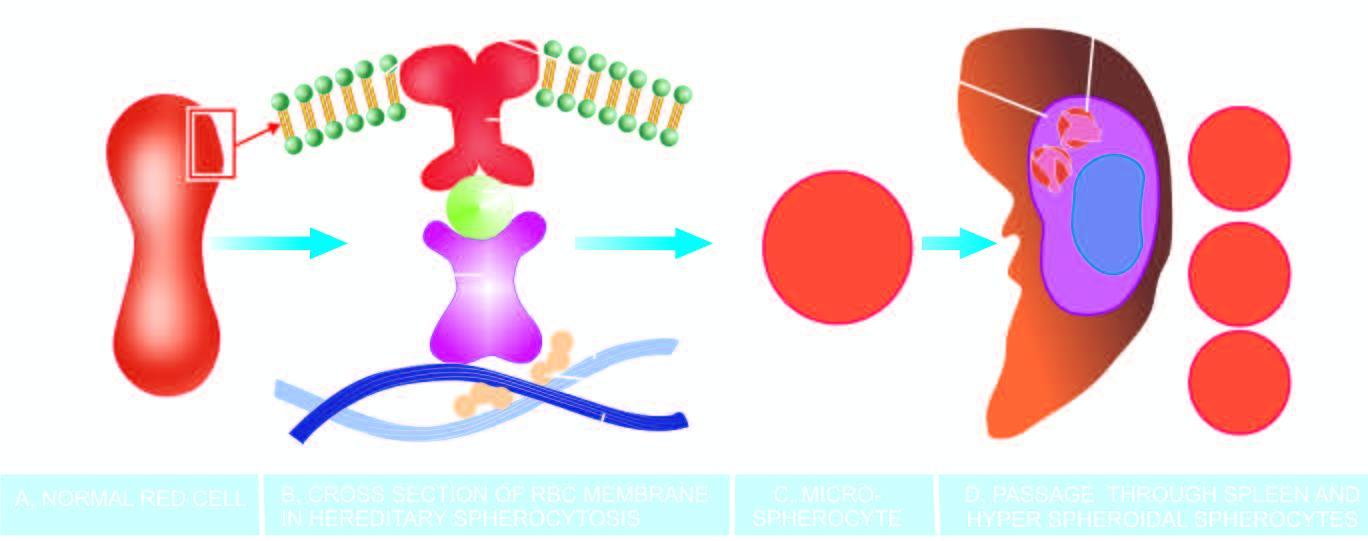do mutations in membrane proteins-alpha-spectrin, beta-spectrin and ankyrin, result in defect in anchoring of lipid bilayer of the membrane to the underlying cytoskeleton?
Answer the question using a single word or phrase. Yes 